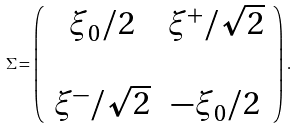<formula> <loc_0><loc_0><loc_500><loc_500>\Sigma = \left ( \begin{array} { c c } \xi _ { 0 } / 2 & \xi ^ { + } / \sqrt { 2 } \\ & \\ \xi ^ { - } / \sqrt { 2 } & - \xi _ { 0 } / 2 \\ \end{array} \right ) \, .</formula> 